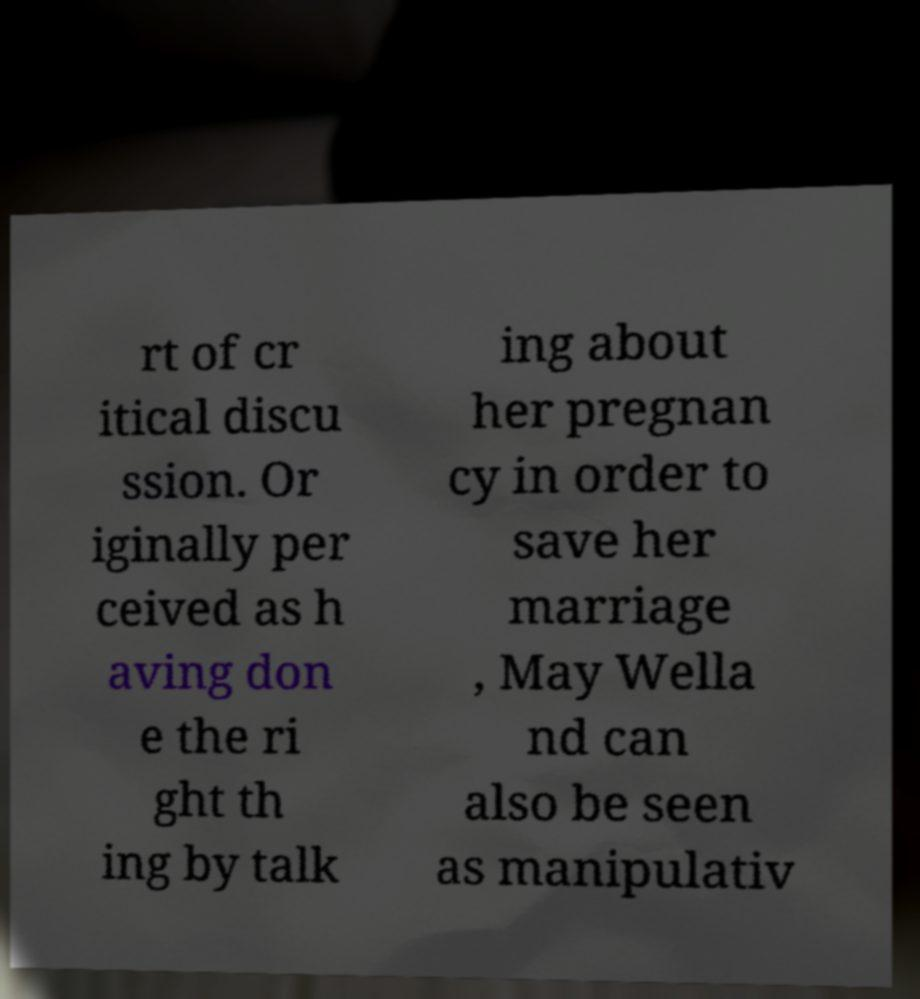What messages or text are displayed in this image? I need them in a readable, typed format. rt of cr itical discu ssion. Or iginally per ceived as h aving don e the ri ght th ing by talk ing about her pregnan cy in order to save her marriage , May Wella nd can also be seen as manipulativ 